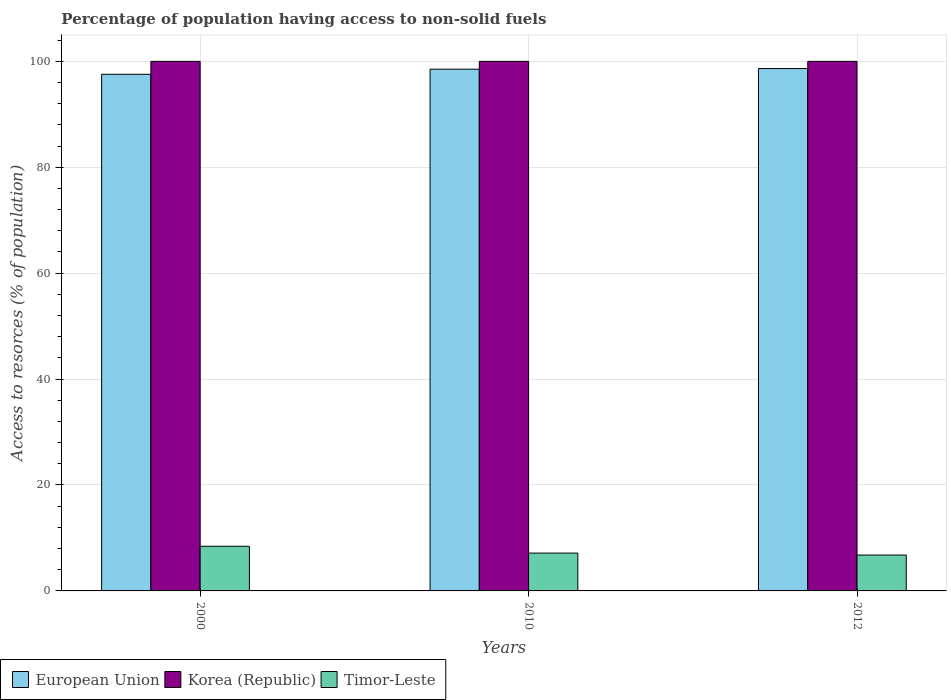How many different coloured bars are there?
Provide a succinct answer. 3. Are the number of bars per tick equal to the number of legend labels?
Provide a succinct answer. Yes. How many bars are there on the 3rd tick from the right?
Your answer should be compact. 3. What is the percentage of population having access to non-solid fuels in European Union in 2000?
Provide a succinct answer. 97.55. Across all years, what is the maximum percentage of population having access to non-solid fuels in European Union?
Your answer should be very brief. 98.63. Across all years, what is the minimum percentage of population having access to non-solid fuels in Korea (Republic)?
Your answer should be very brief. 99.99. What is the total percentage of population having access to non-solid fuels in European Union in the graph?
Keep it short and to the point. 294.69. What is the difference between the percentage of population having access to non-solid fuels in European Union in 2000 and that in 2012?
Offer a very short reply. -1.09. What is the difference between the percentage of population having access to non-solid fuels in Korea (Republic) in 2000 and the percentage of population having access to non-solid fuels in European Union in 2012?
Keep it short and to the point. 1.36. What is the average percentage of population having access to non-solid fuels in European Union per year?
Give a very brief answer. 98.23. In the year 2010, what is the difference between the percentage of population having access to non-solid fuels in Korea (Republic) and percentage of population having access to non-solid fuels in Timor-Leste?
Offer a terse response. 92.85. What is the ratio of the percentage of population having access to non-solid fuels in Korea (Republic) in 2010 to that in 2012?
Offer a terse response. 1. Is the difference between the percentage of population having access to non-solid fuels in Korea (Republic) in 2010 and 2012 greater than the difference between the percentage of population having access to non-solid fuels in Timor-Leste in 2010 and 2012?
Your response must be concise. No. What is the difference between the highest and the second highest percentage of population having access to non-solid fuels in Timor-Leste?
Your answer should be compact. 1.28. What is the difference between the highest and the lowest percentage of population having access to non-solid fuels in European Union?
Provide a short and direct response. 1.09. In how many years, is the percentage of population having access to non-solid fuels in Korea (Republic) greater than the average percentage of population having access to non-solid fuels in Korea (Republic) taken over all years?
Your answer should be very brief. 3. Is the sum of the percentage of population having access to non-solid fuels in Korea (Republic) in 2000 and 2012 greater than the maximum percentage of population having access to non-solid fuels in European Union across all years?
Provide a short and direct response. Yes. What does the 1st bar from the left in 2000 represents?
Make the answer very short. European Union. How many bars are there?
Make the answer very short. 9. Are all the bars in the graph horizontal?
Keep it short and to the point. No. How many years are there in the graph?
Make the answer very short. 3. What is the difference between two consecutive major ticks on the Y-axis?
Ensure brevity in your answer.  20. Are the values on the major ticks of Y-axis written in scientific E-notation?
Offer a very short reply. No. Does the graph contain any zero values?
Your response must be concise. No. Does the graph contain grids?
Offer a terse response. Yes. How many legend labels are there?
Your response must be concise. 3. How are the legend labels stacked?
Provide a succinct answer. Horizontal. What is the title of the graph?
Provide a short and direct response. Percentage of population having access to non-solid fuels. Does "Qatar" appear as one of the legend labels in the graph?
Offer a very short reply. No. What is the label or title of the Y-axis?
Give a very brief answer. Access to resorces (% of population). What is the Access to resorces (% of population) in European Union in 2000?
Provide a short and direct response. 97.55. What is the Access to resorces (% of population) in Korea (Republic) in 2000?
Provide a short and direct response. 99.99. What is the Access to resorces (% of population) in Timor-Leste in 2000?
Provide a short and direct response. 8.43. What is the Access to resorces (% of population) of European Union in 2010?
Provide a succinct answer. 98.51. What is the Access to resorces (% of population) in Korea (Republic) in 2010?
Offer a very short reply. 99.99. What is the Access to resorces (% of population) of Timor-Leste in 2010?
Offer a very short reply. 7.14. What is the Access to resorces (% of population) in European Union in 2012?
Keep it short and to the point. 98.63. What is the Access to resorces (% of population) in Korea (Republic) in 2012?
Provide a succinct answer. 99.99. What is the Access to resorces (% of population) of Timor-Leste in 2012?
Offer a terse response. 6.77. Across all years, what is the maximum Access to resorces (% of population) in European Union?
Provide a succinct answer. 98.63. Across all years, what is the maximum Access to resorces (% of population) in Korea (Republic)?
Ensure brevity in your answer.  99.99. Across all years, what is the maximum Access to resorces (% of population) in Timor-Leste?
Your response must be concise. 8.43. Across all years, what is the minimum Access to resorces (% of population) of European Union?
Keep it short and to the point. 97.55. Across all years, what is the minimum Access to resorces (% of population) of Korea (Republic)?
Keep it short and to the point. 99.99. Across all years, what is the minimum Access to resorces (% of population) of Timor-Leste?
Provide a short and direct response. 6.77. What is the total Access to resorces (% of population) of European Union in the graph?
Your response must be concise. 294.69. What is the total Access to resorces (% of population) of Korea (Republic) in the graph?
Offer a very short reply. 299.97. What is the total Access to resorces (% of population) in Timor-Leste in the graph?
Your response must be concise. 22.35. What is the difference between the Access to resorces (% of population) of European Union in 2000 and that in 2010?
Make the answer very short. -0.96. What is the difference between the Access to resorces (% of population) of Timor-Leste in 2000 and that in 2010?
Offer a very short reply. 1.28. What is the difference between the Access to resorces (% of population) in European Union in 2000 and that in 2012?
Your response must be concise. -1.09. What is the difference between the Access to resorces (% of population) of Timor-Leste in 2000 and that in 2012?
Give a very brief answer. 1.65. What is the difference between the Access to resorces (% of population) in European Union in 2010 and that in 2012?
Give a very brief answer. -0.12. What is the difference between the Access to resorces (% of population) of Korea (Republic) in 2010 and that in 2012?
Offer a terse response. 0. What is the difference between the Access to resorces (% of population) of Timor-Leste in 2010 and that in 2012?
Offer a terse response. 0.37. What is the difference between the Access to resorces (% of population) of European Union in 2000 and the Access to resorces (% of population) of Korea (Republic) in 2010?
Your answer should be very brief. -2.44. What is the difference between the Access to resorces (% of population) of European Union in 2000 and the Access to resorces (% of population) of Timor-Leste in 2010?
Provide a succinct answer. 90.4. What is the difference between the Access to resorces (% of population) of Korea (Republic) in 2000 and the Access to resorces (% of population) of Timor-Leste in 2010?
Provide a succinct answer. 92.85. What is the difference between the Access to resorces (% of population) in European Union in 2000 and the Access to resorces (% of population) in Korea (Republic) in 2012?
Provide a short and direct response. -2.44. What is the difference between the Access to resorces (% of population) in European Union in 2000 and the Access to resorces (% of population) in Timor-Leste in 2012?
Your answer should be compact. 90.77. What is the difference between the Access to resorces (% of population) in Korea (Republic) in 2000 and the Access to resorces (% of population) in Timor-Leste in 2012?
Keep it short and to the point. 93.22. What is the difference between the Access to resorces (% of population) of European Union in 2010 and the Access to resorces (% of population) of Korea (Republic) in 2012?
Make the answer very short. -1.48. What is the difference between the Access to resorces (% of population) of European Union in 2010 and the Access to resorces (% of population) of Timor-Leste in 2012?
Your answer should be very brief. 91.74. What is the difference between the Access to resorces (% of population) of Korea (Republic) in 2010 and the Access to resorces (% of population) of Timor-Leste in 2012?
Make the answer very short. 93.22. What is the average Access to resorces (% of population) in European Union per year?
Your answer should be very brief. 98.23. What is the average Access to resorces (% of population) in Korea (Republic) per year?
Give a very brief answer. 99.99. What is the average Access to resorces (% of population) in Timor-Leste per year?
Offer a very short reply. 7.45. In the year 2000, what is the difference between the Access to resorces (% of population) in European Union and Access to resorces (% of population) in Korea (Republic)?
Ensure brevity in your answer.  -2.44. In the year 2000, what is the difference between the Access to resorces (% of population) of European Union and Access to resorces (% of population) of Timor-Leste?
Give a very brief answer. 89.12. In the year 2000, what is the difference between the Access to resorces (% of population) of Korea (Republic) and Access to resorces (% of population) of Timor-Leste?
Offer a terse response. 91.56. In the year 2010, what is the difference between the Access to resorces (% of population) in European Union and Access to resorces (% of population) in Korea (Republic)?
Your answer should be very brief. -1.48. In the year 2010, what is the difference between the Access to resorces (% of population) of European Union and Access to resorces (% of population) of Timor-Leste?
Ensure brevity in your answer.  91.37. In the year 2010, what is the difference between the Access to resorces (% of population) in Korea (Republic) and Access to resorces (% of population) in Timor-Leste?
Offer a terse response. 92.85. In the year 2012, what is the difference between the Access to resorces (% of population) of European Union and Access to resorces (% of population) of Korea (Republic)?
Keep it short and to the point. -1.36. In the year 2012, what is the difference between the Access to resorces (% of population) in European Union and Access to resorces (% of population) in Timor-Leste?
Offer a very short reply. 91.86. In the year 2012, what is the difference between the Access to resorces (% of population) in Korea (Republic) and Access to resorces (% of population) in Timor-Leste?
Offer a terse response. 93.22. What is the ratio of the Access to resorces (% of population) of European Union in 2000 to that in 2010?
Ensure brevity in your answer.  0.99. What is the ratio of the Access to resorces (% of population) of Korea (Republic) in 2000 to that in 2010?
Provide a succinct answer. 1. What is the ratio of the Access to resorces (% of population) of Timor-Leste in 2000 to that in 2010?
Provide a short and direct response. 1.18. What is the ratio of the Access to resorces (% of population) in European Union in 2000 to that in 2012?
Make the answer very short. 0.99. What is the ratio of the Access to resorces (% of population) in Korea (Republic) in 2000 to that in 2012?
Offer a terse response. 1. What is the ratio of the Access to resorces (% of population) in Timor-Leste in 2000 to that in 2012?
Make the answer very short. 1.24. What is the ratio of the Access to resorces (% of population) of European Union in 2010 to that in 2012?
Your answer should be very brief. 1. What is the ratio of the Access to resorces (% of population) of Timor-Leste in 2010 to that in 2012?
Your answer should be very brief. 1.05. What is the difference between the highest and the second highest Access to resorces (% of population) of European Union?
Ensure brevity in your answer.  0.12. What is the difference between the highest and the second highest Access to resorces (% of population) in Timor-Leste?
Make the answer very short. 1.28. What is the difference between the highest and the lowest Access to resorces (% of population) in European Union?
Give a very brief answer. 1.09. What is the difference between the highest and the lowest Access to resorces (% of population) in Timor-Leste?
Offer a very short reply. 1.65. 